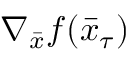<formula> <loc_0><loc_0><loc_500><loc_500>\nabla _ { \bar { x } } f ( \bar { x } _ { \tau } )</formula> 